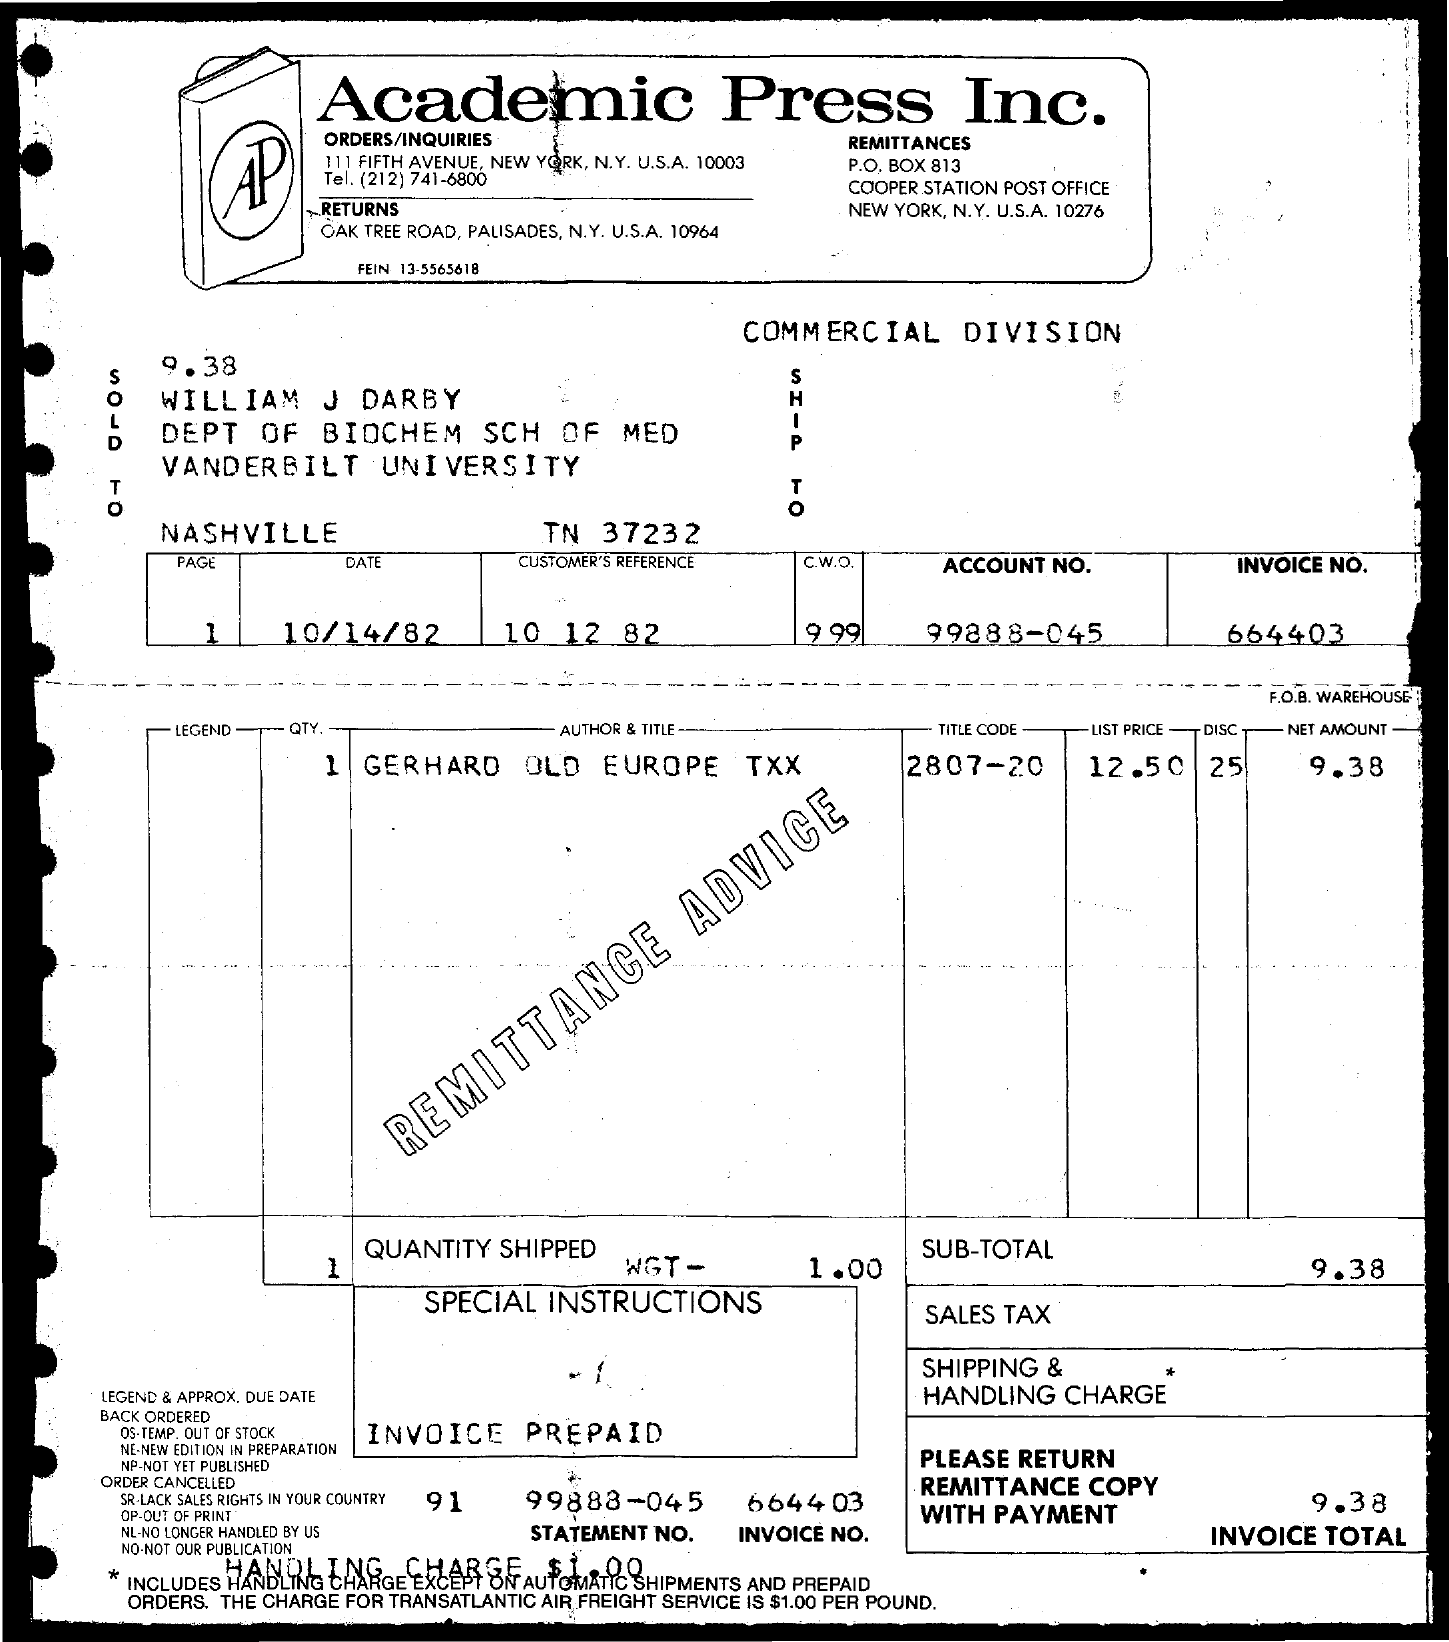What is the title code of gerhard old europe txx ?
Give a very brief answer. 2807-20. What is the list price of gerhard old europe txx ?
Give a very brief answer. 12.50. What is the net amount of gerhard old europe txx?
Offer a very short reply. 9.38. What is the statement no.?
Provide a succinct answer. 99888-045. What is the invoice no?
Give a very brief answer. 664403. 